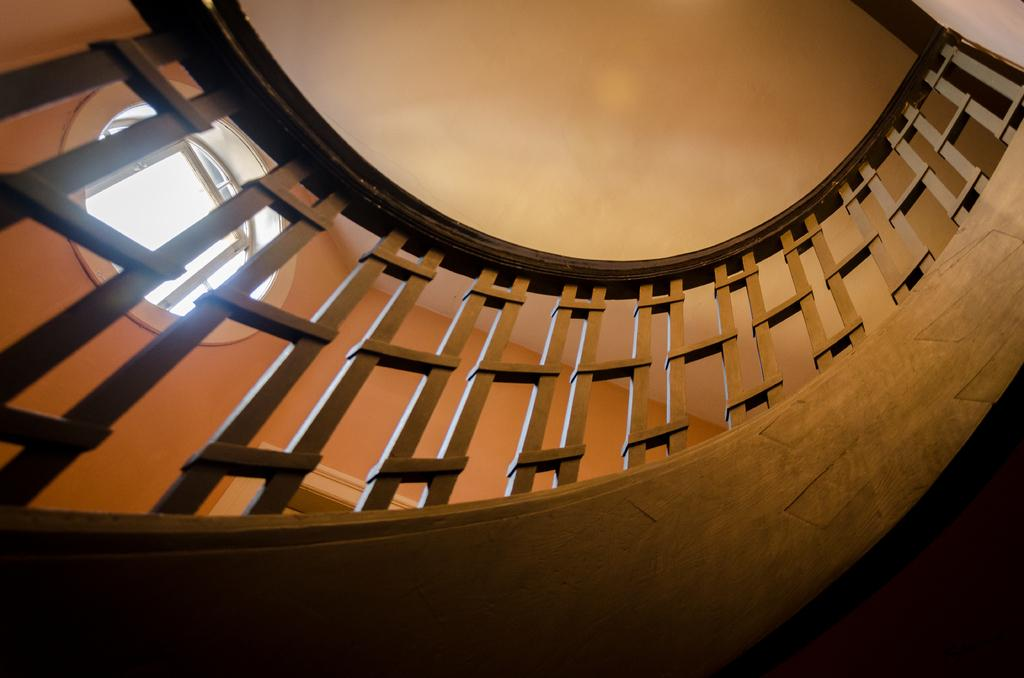What can be seen in the foreground of the image? There is a railing in the foreground of the image. What is visible at the top of the image? The roof is visible at the top of the image. What is located in the background of the image? There is a wall and a window in the background of the image. What type of meat is being prepared on the grill in the image? There is no grill or meat present in the image. How much juice can be seen flowing from the fruit in the image? There is no fruit or juice present in the image. 